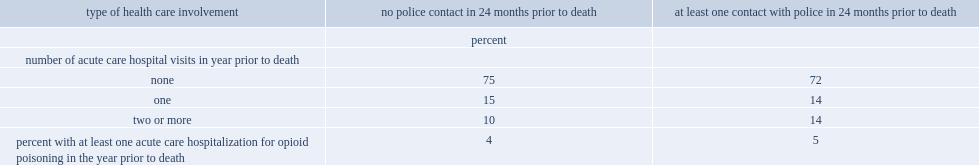Which group of decendents were most among all the decedents who did not contact with police and had at least one contact with police in 24 monts prior to death, those who were not hospitalized, or those who had one or two more hospital visits in year prior to death? None. Among all the decedents who did not have contact with police in 24 months prior to deaths, what is the percentage of those who were not hospitalized in year prior to death? 75.0. Which group of decedents were more likely to have been hospitalized two or more times in the year before their death, those who had come into contact with police or those who hadn't come into contact with police? At least one contact with police in 24 months prior to death. Among decedents who had contact with police in 24 months prior to death, what is the percentage of those who were hospitalized at least once in the year before their death as a result of opioid poisoning? 5.0. Among decedents who hadn't contact with police in 24 months prior to death, what is the percentage of those who were hospitalized at least once in the year before their death as a result of opioid poisoning? 4.0. 